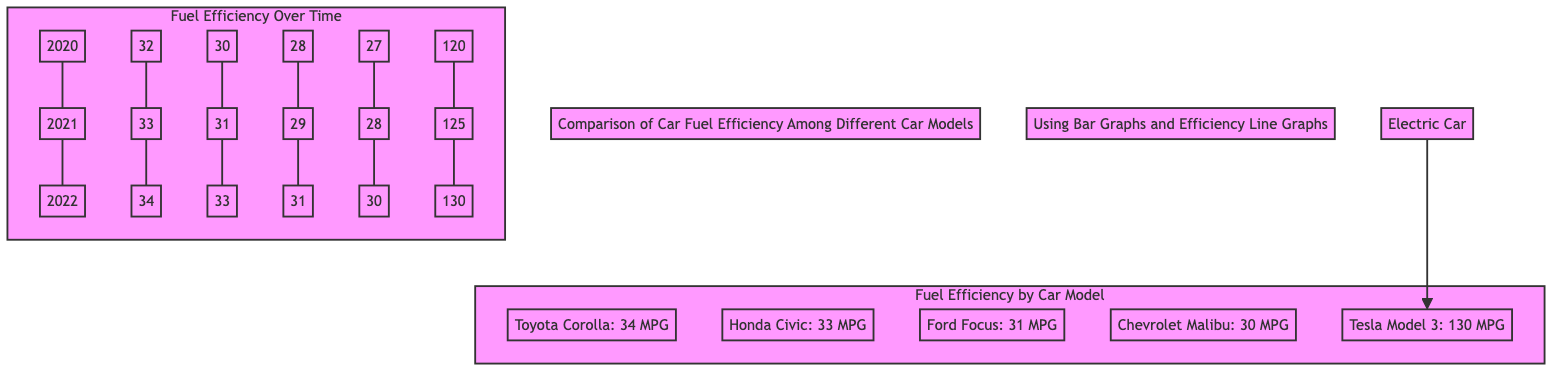What is the fuel efficiency of the Tesla Model 3? The diagram shows that the Tesla Model 3 is labeled with 130 MPG under the "Fuel Efficiency by Car Model" section.
Answer: 130 MPG Which car has the lowest fuel efficiency? The bar graph indicates that the Chevrolet Malibu has the lowest fuel efficiency, marked at 30 MPG.
Answer: Chevrolet Malibu How many car models are compared in the diagram? In the "Fuel Efficiency by Car Model" section, there are five car models: Toyota Corolla, Honda Civic, Ford Focus, Chevrolet Malibu, and Tesla Model 3.
Answer: Five What was Toyota's fuel efficiency in 2021? The "Fuel Efficiency Over Time" section shows Toyota's values across the years. For 2021, the value is 33 MPG.
Answer: 33 MPG Which car model shows the highest improvement from 2020 to 2022? Analyzing the data, the Toyota Corolla increased from 32 MPG in 2020 to 34 MPG in 2022. The increase is 2 MPG, which is the highest among the models.
Answer: Toyota Corolla How many MPG does the Honda Civic show in 2022? Looking at the "Fuel Efficiency Over Time" section for Honda Civic, the value is 33 MPG for the year 2022.
Answer: 33 MPG What is the total number of efficiency points shown for the Ford Focus from 2020 to 2022? The points for Ford Focus are 28 MPG for 2020, 29 MPG for 2021, and 31 MPG for 2022. Adding these, the total is 88 MPG across the three years.
Answer: 88 MPG What color denotes the electric car in the diagram? The electric car, represented by the Tesla, is highlighted in purple as shown in the diagram's color coding.
Answer: Purple What was the trend for Tesla's fuel efficiency from 2020 to 2022? The efficiency line rises steadily from 120 MPG in 2020 to 130 MPG in 2022, indicating a consistent increase over the three years.
Answer: Increasing 